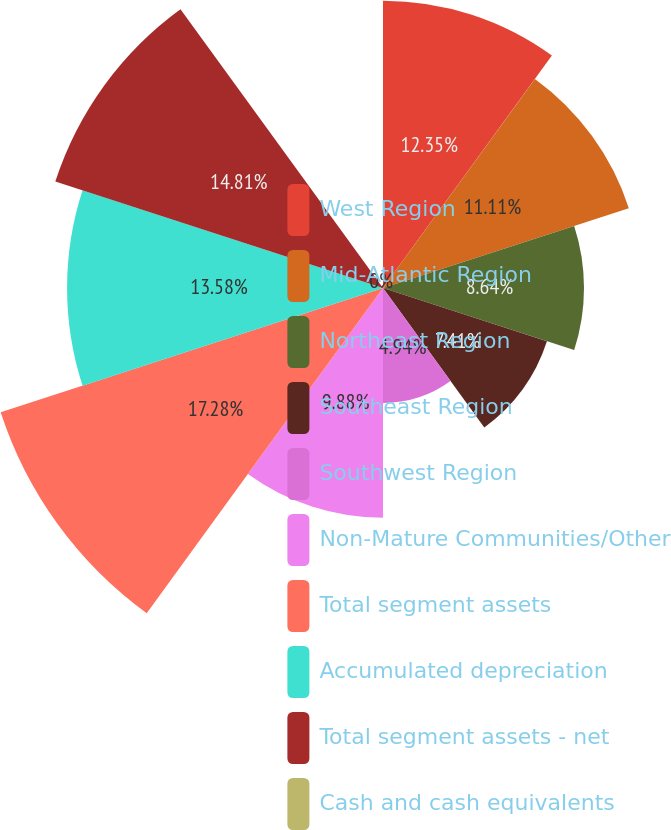Convert chart to OTSL. <chart><loc_0><loc_0><loc_500><loc_500><pie_chart><fcel>West Region<fcel>Mid-Atlantic Region<fcel>Northeast Region<fcel>Southeast Region<fcel>Southwest Region<fcel>Non-Mature Communities/Other<fcel>Total segment assets<fcel>Accumulated depreciation<fcel>Total segment assets - net<fcel>Cash and cash equivalents<nl><fcel>12.35%<fcel>11.11%<fcel>8.64%<fcel>7.41%<fcel>4.94%<fcel>9.88%<fcel>17.28%<fcel>13.58%<fcel>14.81%<fcel>0.0%<nl></chart> 